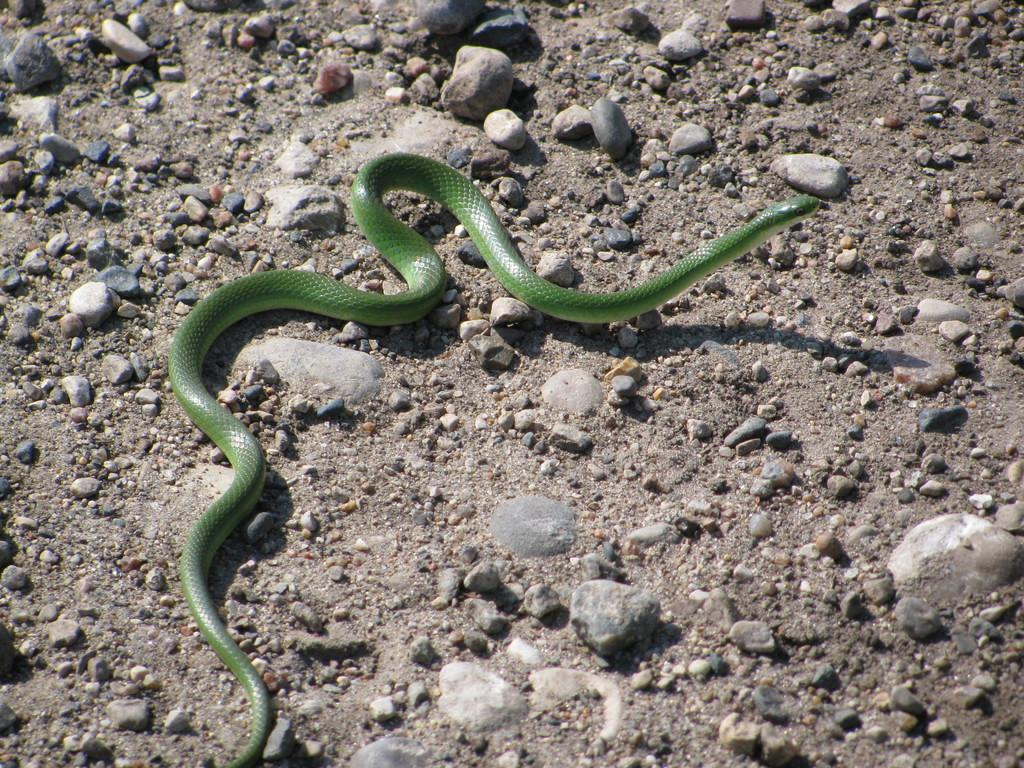Where was the image taken? The image was taken outdoors. What type of surface is visible at the bottom of the image? There is a ground with pebbles at the bottom of the image. What can be seen in the middle of the image? There is a green area in the middle of the image. What type of oatmeal is being served in the green area of the image? There is no oatmeal present in the image, and the green area does not depict any food or beverage. 